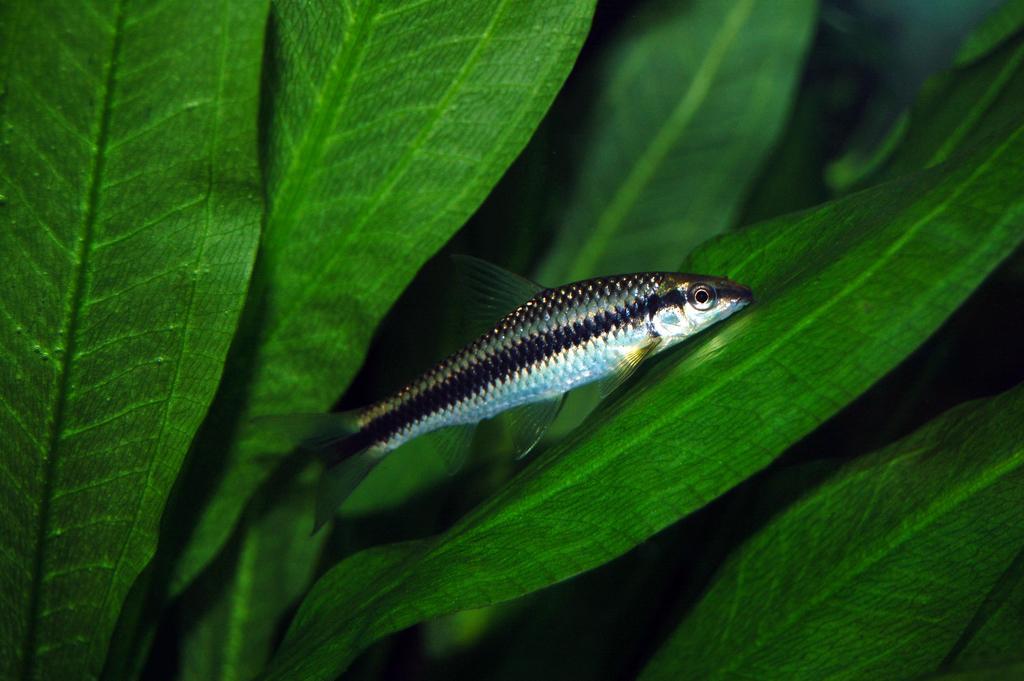Can you describe this image briefly? In the image we can see a fish. Behind the fish there are some leaves. 